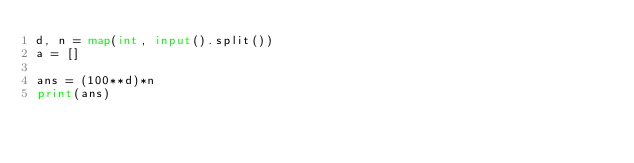Convert code to text. <code><loc_0><loc_0><loc_500><loc_500><_Python_>d, n = map(int, input().split())
a = []

ans = (100**d)*n
print(ans)</code> 